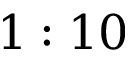Convert formula to latex. <formula><loc_0><loc_0><loc_500><loc_500>1 \colon 1 0</formula> 